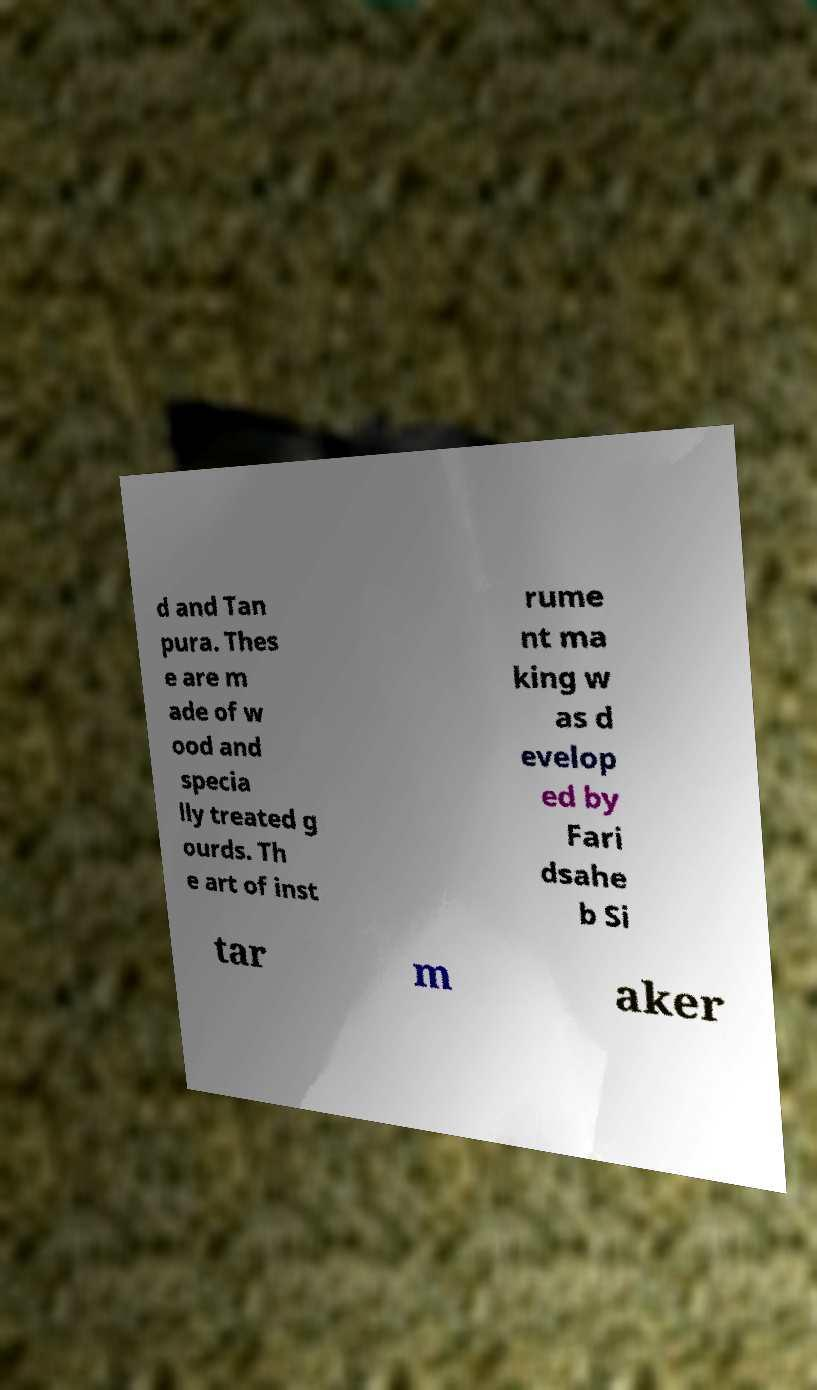Can you accurately transcribe the text from the provided image for me? d and Tan pura. Thes e are m ade of w ood and specia lly treated g ourds. Th e art of inst rume nt ma king w as d evelop ed by Fari dsahe b Si tar m aker 